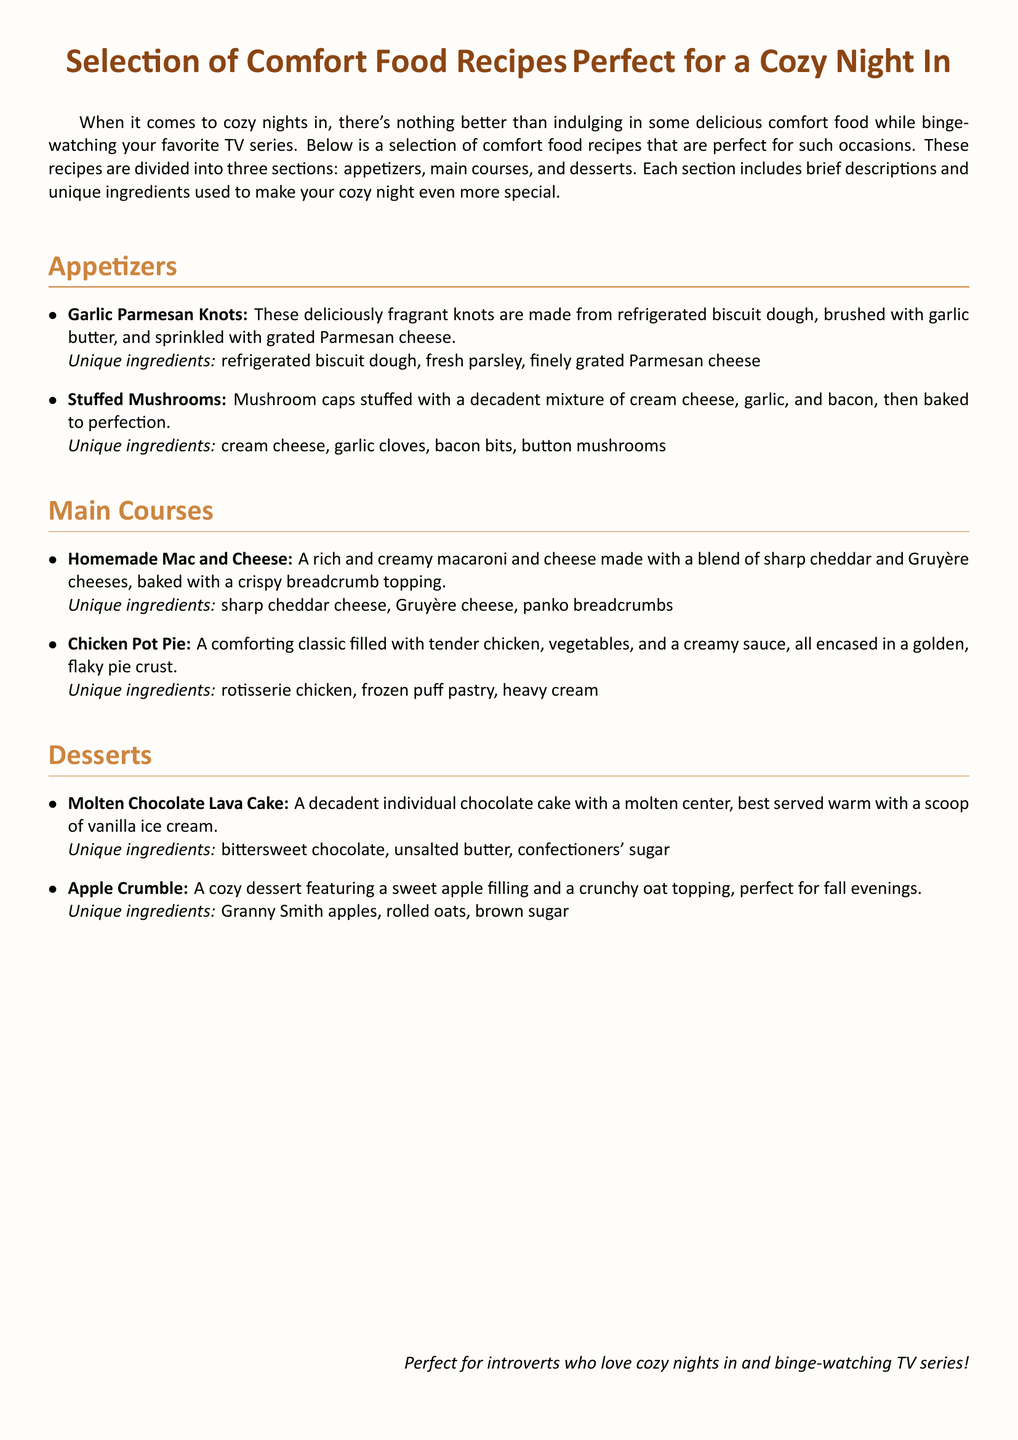What are the unique ingredients for Garlic Parmesan Knots? The unique ingredients are listed in the document under the Garlic Parmesan Knots description.
Answer: refrigerated biscuit dough, fresh parsley, finely grated Parmesan cheese What is the main ingredient used in Stuffed Mushrooms? The main ingredient can be identified in the Stuffed Mushrooms description, highlighting what fills the mushroom caps.
Answer: cream cheese How many main courses are listed in the document? By counting the items in the main courses section, we find the total number of recipes.
Answer: 2 What type of cheese is used in Homemade Mac and Cheese? The type of cheese is specified in the unique ingredients for the Homemade Mac and Cheese recipe.
Answer: Gruyère cheese What is the topping for the Apple Crumble? The document describes the Apple Crumble's topping in the unique ingredients section.
Answer: crunchy oat topping Which dessert is best served warm? This information is found in the description of the Molten Chocolate Lava Cake, indicating its serving preference.
Answer: Molten Chocolate Lava Cake What key ingredient is included in Chicken Pot Pie? The key ingredient can be derived from the description of the Chicken Pot Pie in the main courses section.
Answer: rotisserie chicken How many appetizers are featured in the document? The total number of appetizers can be counted from the appetizers section of the document.
Answer: 2 